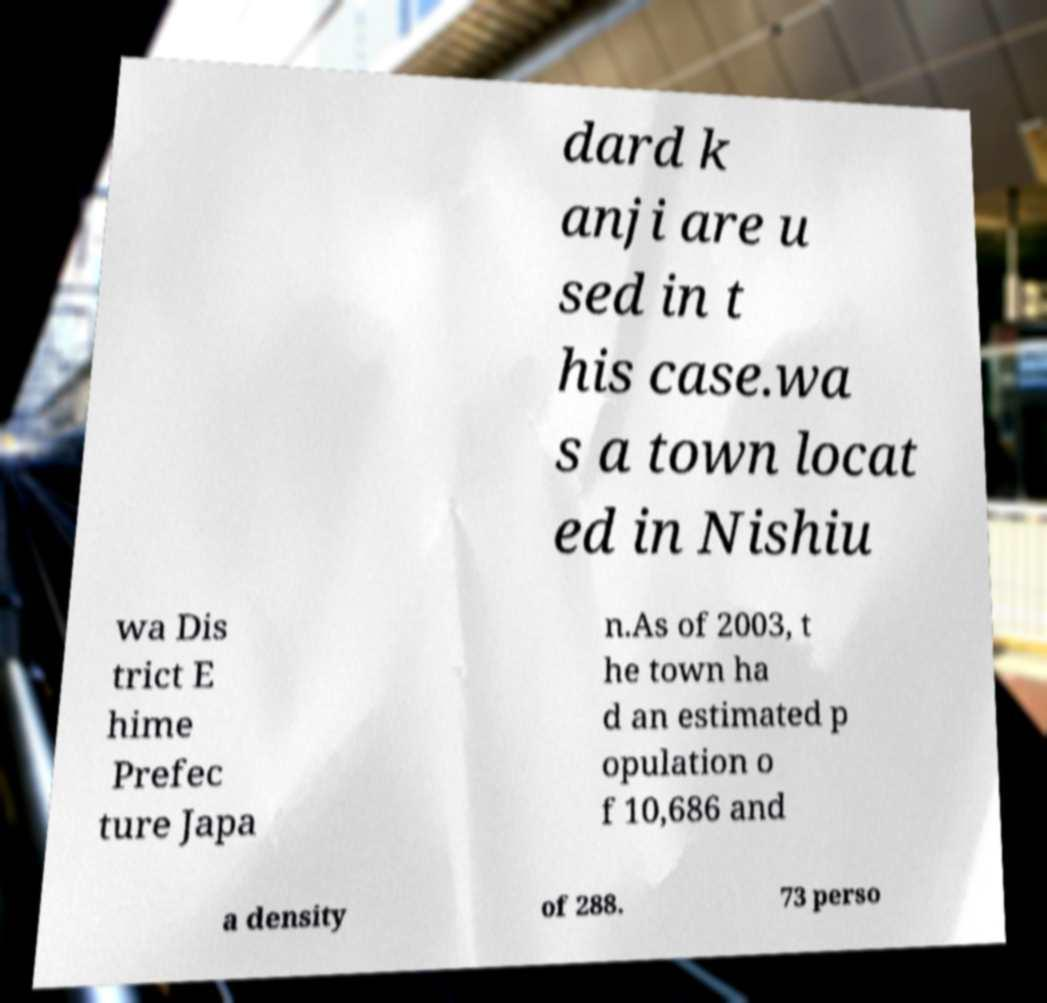There's text embedded in this image that I need extracted. Can you transcribe it verbatim? dard k anji are u sed in t his case.wa s a town locat ed in Nishiu wa Dis trict E hime Prefec ture Japa n.As of 2003, t he town ha d an estimated p opulation o f 10,686 and a density of 288. 73 perso 